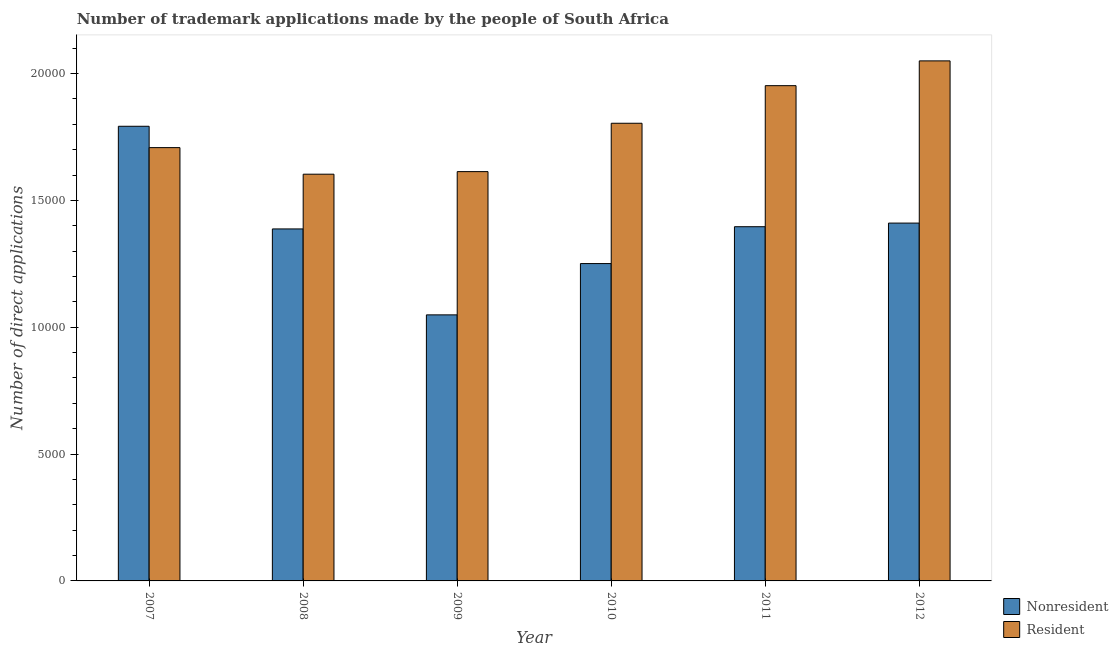How many groups of bars are there?
Your answer should be compact. 6. Are the number of bars per tick equal to the number of legend labels?
Provide a short and direct response. Yes. Are the number of bars on each tick of the X-axis equal?
Provide a short and direct response. Yes. How many bars are there on the 5th tick from the right?
Make the answer very short. 2. What is the label of the 2nd group of bars from the left?
Ensure brevity in your answer.  2008. In how many cases, is the number of bars for a given year not equal to the number of legend labels?
Offer a terse response. 0. What is the number of trademark applications made by residents in 2008?
Offer a very short reply. 1.60e+04. Across all years, what is the maximum number of trademark applications made by residents?
Your answer should be compact. 2.05e+04. Across all years, what is the minimum number of trademark applications made by non residents?
Provide a succinct answer. 1.05e+04. In which year was the number of trademark applications made by residents minimum?
Provide a succinct answer. 2008. What is the total number of trademark applications made by non residents in the graph?
Ensure brevity in your answer.  8.29e+04. What is the difference between the number of trademark applications made by residents in 2008 and that in 2010?
Make the answer very short. -2008. What is the difference between the number of trademark applications made by non residents in 2012 and the number of trademark applications made by residents in 2009?
Give a very brief answer. 3618. What is the average number of trademark applications made by residents per year?
Keep it short and to the point. 1.79e+04. In the year 2012, what is the difference between the number of trademark applications made by non residents and number of trademark applications made by residents?
Keep it short and to the point. 0. In how many years, is the number of trademark applications made by residents greater than 16000?
Offer a very short reply. 6. What is the ratio of the number of trademark applications made by residents in 2007 to that in 2008?
Offer a terse response. 1.07. Is the number of trademark applications made by non residents in 2008 less than that in 2011?
Your response must be concise. Yes. Is the difference between the number of trademark applications made by residents in 2007 and 2010 greater than the difference between the number of trademark applications made by non residents in 2007 and 2010?
Offer a very short reply. No. What is the difference between the highest and the second highest number of trademark applications made by non residents?
Your answer should be very brief. 3816. What is the difference between the highest and the lowest number of trademark applications made by non residents?
Make the answer very short. 7434. In how many years, is the number of trademark applications made by non residents greater than the average number of trademark applications made by non residents taken over all years?
Offer a very short reply. 4. What does the 1st bar from the left in 2012 represents?
Ensure brevity in your answer.  Nonresident. What does the 2nd bar from the right in 2008 represents?
Your answer should be very brief. Nonresident. How many bars are there?
Provide a short and direct response. 12. Are all the bars in the graph horizontal?
Your answer should be very brief. No. Does the graph contain any zero values?
Offer a terse response. No. Does the graph contain grids?
Give a very brief answer. No. Where does the legend appear in the graph?
Provide a succinct answer. Bottom right. What is the title of the graph?
Make the answer very short. Number of trademark applications made by the people of South Africa. Does "International Tourists" appear as one of the legend labels in the graph?
Ensure brevity in your answer.  No. What is the label or title of the Y-axis?
Make the answer very short. Number of direct applications. What is the Number of direct applications of Nonresident in 2007?
Your answer should be compact. 1.79e+04. What is the Number of direct applications in Resident in 2007?
Make the answer very short. 1.71e+04. What is the Number of direct applications of Nonresident in 2008?
Ensure brevity in your answer.  1.39e+04. What is the Number of direct applications of Resident in 2008?
Your answer should be very brief. 1.60e+04. What is the Number of direct applications in Nonresident in 2009?
Your answer should be very brief. 1.05e+04. What is the Number of direct applications in Resident in 2009?
Offer a very short reply. 1.61e+04. What is the Number of direct applications in Nonresident in 2010?
Ensure brevity in your answer.  1.25e+04. What is the Number of direct applications of Resident in 2010?
Offer a very short reply. 1.80e+04. What is the Number of direct applications in Nonresident in 2011?
Provide a short and direct response. 1.40e+04. What is the Number of direct applications in Resident in 2011?
Provide a succinct answer. 1.95e+04. What is the Number of direct applications in Nonresident in 2012?
Keep it short and to the point. 1.41e+04. What is the Number of direct applications of Resident in 2012?
Your answer should be compact. 2.05e+04. Across all years, what is the maximum Number of direct applications in Nonresident?
Offer a terse response. 1.79e+04. Across all years, what is the maximum Number of direct applications in Resident?
Offer a very short reply. 2.05e+04. Across all years, what is the minimum Number of direct applications in Nonresident?
Your answer should be compact. 1.05e+04. Across all years, what is the minimum Number of direct applications of Resident?
Offer a terse response. 1.60e+04. What is the total Number of direct applications in Nonresident in the graph?
Keep it short and to the point. 8.29e+04. What is the total Number of direct applications of Resident in the graph?
Offer a very short reply. 1.07e+05. What is the difference between the Number of direct applications in Nonresident in 2007 and that in 2008?
Provide a succinct answer. 4046. What is the difference between the Number of direct applications of Resident in 2007 and that in 2008?
Your answer should be compact. 1048. What is the difference between the Number of direct applications in Nonresident in 2007 and that in 2009?
Give a very brief answer. 7434. What is the difference between the Number of direct applications in Resident in 2007 and that in 2009?
Make the answer very short. 946. What is the difference between the Number of direct applications in Nonresident in 2007 and that in 2010?
Your answer should be very brief. 5412. What is the difference between the Number of direct applications of Resident in 2007 and that in 2010?
Provide a succinct answer. -960. What is the difference between the Number of direct applications in Nonresident in 2007 and that in 2011?
Keep it short and to the point. 3959. What is the difference between the Number of direct applications of Resident in 2007 and that in 2011?
Keep it short and to the point. -2442. What is the difference between the Number of direct applications of Nonresident in 2007 and that in 2012?
Your answer should be compact. 3816. What is the difference between the Number of direct applications of Resident in 2007 and that in 2012?
Give a very brief answer. -3419. What is the difference between the Number of direct applications of Nonresident in 2008 and that in 2009?
Ensure brevity in your answer.  3388. What is the difference between the Number of direct applications in Resident in 2008 and that in 2009?
Give a very brief answer. -102. What is the difference between the Number of direct applications of Nonresident in 2008 and that in 2010?
Offer a very short reply. 1366. What is the difference between the Number of direct applications of Resident in 2008 and that in 2010?
Make the answer very short. -2008. What is the difference between the Number of direct applications of Nonresident in 2008 and that in 2011?
Your answer should be compact. -87. What is the difference between the Number of direct applications in Resident in 2008 and that in 2011?
Your answer should be very brief. -3490. What is the difference between the Number of direct applications in Nonresident in 2008 and that in 2012?
Make the answer very short. -230. What is the difference between the Number of direct applications of Resident in 2008 and that in 2012?
Your response must be concise. -4467. What is the difference between the Number of direct applications of Nonresident in 2009 and that in 2010?
Provide a succinct answer. -2022. What is the difference between the Number of direct applications of Resident in 2009 and that in 2010?
Your response must be concise. -1906. What is the difference between the Number of direct applications of Nonresident in 2009 and that in 2011?
Your answer should be very brief. -3475. What is the difference between the Number of direct applications in Resident in 2009 and that in 2011?
Give a very brief answer. -3388. What is the difference between the Number of direct applications in Nonresident in 2009 and that in 2012?
Make the answer very short. -3618. What is the difference between the Number of direct applications of Resident in 2009 and that in 2012?
Keep it short and to the point. -4365. What is the difference between the Number of direct applications in Nonresident in 2010 and that in 2011?
Your answer should be compact. -1453. What is the difference between the Number of direct applications in Resident in 2010 and that in 2011?
Offer a very short reply. -1482. What is the difference between the Number of direct applications in Nonresident in 2010 and that in 2012?
Make the answer very short. -1596. What is the difference between the Number of direct applications of Resident in 2010 and that in 2012?
Provide a short and direct response. -2459. What is the difference between the Number of direct applications in Nonresident in 2011 and that in 2012?
Offer a very short reply. -143. What is the difference between the Number of direct applications in Resident in 2011 and that in 2012?
Offer a terse response. -977. What is the difference between the Number of direct applications of Nonresident in 2007 and the Number of direct applications of Resident in 2008?
Keep it short and to the point. 1889. What is the difference between the Number of direct applications of Nonresident in 2007 and the Number of direct applications of Resident in 2009?
Offer a very short reply. 1787. What is the difference between the Number of direct applications in Nonresident in 2007 and the Number of direct applications in Resident in 2010?
Give a very brief answer. -119. What is the difference between the Number of direct applications in Nonresident in 2007 and the Number of direct applications in Resident in 2011?
Keep it short and to the point. -1601. What is the difference between the Number of direct applications in Nonresident in 2007 and the Number of direct applications in Resident in 2012?
Your answer should be compact. -2578. What is the difference between the Number of direct applications in Nonresident in 2008 and the Number of direct applications in Resident in 2009?
Your response must be concise. -2259. What is the difference between the Number of direct applications in Nonresident in 2008 and the Number of direct applications in Resident in 2010?
Keep it short and to the point. -4165. What is the difference between the Number of direct applications of Nonresident in 2008 and the Number of direct applications of Resident in 2011?
Your response must be concise. -5647. What is the difference between the Number of direct applications of Nonresident in 2008 and the Number of direct applications of Resident in 2012?
Offer a terse response. -6624. What is the difference between the Number of direct applications of Nonresident in 2009 and the Number of direct applications of Resident in 2010?
Your answer should be very brief. -7553. What is the difference between the Number of direct applications of Nonresident in 2009 and the Number of direct applications of Resident in 2011?
Offer a terse response. -9035. What is the difference between the Number of direct applications of Nonresident in 2009 and the Number of direct applications of Resident in 2012?
Provide a short and direct response. -1.00e+04. What is the difference between the Number of direct applications in Nonresident in 2010 and the Number of direct applications in Resident in 2011?
Your response must be concise. -7013. What is the difference between the Number of direct applications in Nonresident in 2010 and the Number of direct applications in Resident in 2012?
Offer a very short reply. -7990. What is the difference between the Number of direct applications of Nonresident in 2011 and the Number of direct applications of Resident in 2012?
Your answer should be very brief. -6537. What is the average Number of direct applications of Nonresident per year?
Your answer should be very brief. 1.38e+04. What is the average Number of direct applications in Resident per year?
Provide a succinct answer. 1.79e+04. In the year 2007, what is the difference between the Number of direct applications of Nonresident and Number of direct applications of Resident?
Offer a terse response. 841. In the year 2008, what is the difference between the Number of direct applications of Nonresident and Number of direct applications of Resident?
Make the answer very short. -2157. In the year 2009, what is the difference between the Number of direct applications of Nonresident and Number of direct applications of Resident?
Offer a terse response. -5647. In the year 2010, what is the difference between the Number of direct applications of Nonresident and Number of direct applications of Resident?
Make the answer very short. -5531. In the year 2011, what is the difference between the Number of direct applications in Nonresident and Number of direct applications in Resident?
Offer a very short reply. -5560. In the year 2012, what is the difference between the Number of direct applications of Nonresident and Number of direct applications of Resident?
Give a very brief answer. -6394. What is the ratio of the Number of direct applications of Nonresident in 2007 to that in 2008?
Keep it short and to the point. 1.29. What is the ratio of the Number of direct applications in Resident in 2007 to that in 2008?
Give a very brief answer. 1.07. What is the ratio of the Number of direct applications of Nonresident in 2007 to that in 2009?
Offer a very short reply. 1.71. What is the ratio of the Number of direct applications in Resident in 2007 to that in 2009?
Offer a terse response. 1.06. What is the ratio of the Number of direct applications of Nonresident in 2007 to that in 2010?
Offer a very short reply. 1.43. What is the ratio of the Number of direct applications of Resident in 2007 to that in 2010?
Your response must be concise. 0.95. What is the ratio of the Number of direct applications of Nonresident in 2007 to that in 2011?
Provide a succinct answer. 1.28. What is the ratio of the Number of direct applications of Resident in 2007 to that in 2011?
Your response must be concise. 0.87. What is the ratio of the Number of direct applications in Nonresident in 2007 to that in 2012?
Make the answer very short. 1.27. What is the ratio of the Number of direct applications in Resident in 2007 to that in 2012?
Give a very brief answer. 0.83. What is the ratio of the Number of direct applications in Nonresident in 2008 to that in 2009?
Keep it short and to the point. 1.32. What is the ratio of the Number of direct applications of Nonresident in 2008 to that in 2010?
Your response must be concise. 1.11. What is the ratio of the Number of direct applications of Resident in 2008 to that in 2010?
Offer a terse response. 0.89. What is the ratio of the Number of direct applications of Resident in 2008 to that in 2011?
Your response must be concise. 0.82. What is the ratio of the Number of direct applications of Nonresident in 2008 to that in 2012?
Provide a short and direct response. 0.98. What is the ratio of the Number of direct applications in Resident in 2008 to that in 2012?
Your answer should be very brief. 0.78. What is the ratio of the Number of direct applications of Nonresident in 2009 to that in 2010?
Offer a very short reply. 0.84. What is the ratio of the Number of direct applications in Resident in 2009 to that in 2010?
Provide a short and direct response. 0.89. What is the ratio of the Number of direct applications of Nonresident in 2009 to that in 2011?
Ensure brevity in your answer.  0.75. What is the ratio of the Number of direct applications in Resident in 2009 to that in 2011?
Offer a terse response. 0.83. What is the ratio of the Number of direct applications in Nonresident in 2009 to that in 2012?
Ensure brevity in your answer.  0.74. What is the ratio of the Number of direct applications in Resident in 2009 to that in 2012?
Your response must be concise. 0.79. What is the ratio of the Number of direct applications of Nonresident in 2010 to that in 2011?
Offer a terse response. 0.9. What is the ratio of the Number of direct applications in Resident in 2010 to that in 2011?
Make the answer very short. 0.92. What is the ratio of the Number of direct applications in Nonresident in 2010 to that in 2012?
Provide a succinct answer. 0.89. What is the ratio of the Number of direct applications of Nonresident in 2011 to that in 2012?
Ensure brevity in your answer.  0.99. What is the ratio of the Number of direct applications in Resident in 2011 to that in 2012?
Offer a very short reply. 0.95. What is the difference between the highest and the second highest Number of direct applications in Nonresident?
Ensure brevity in your answer.  3816. What is the difference between the highest and the second highest Number of direct applications in Resident?
Keep it short and to the point. 977. What is the difference between the highest and the lowest Number of direct applications in Nonresident?
Your response must be concise. 7434. What is the difference between the highest and the lowest Number of direct applications in Resident?
Your response must be concise. 4467. 